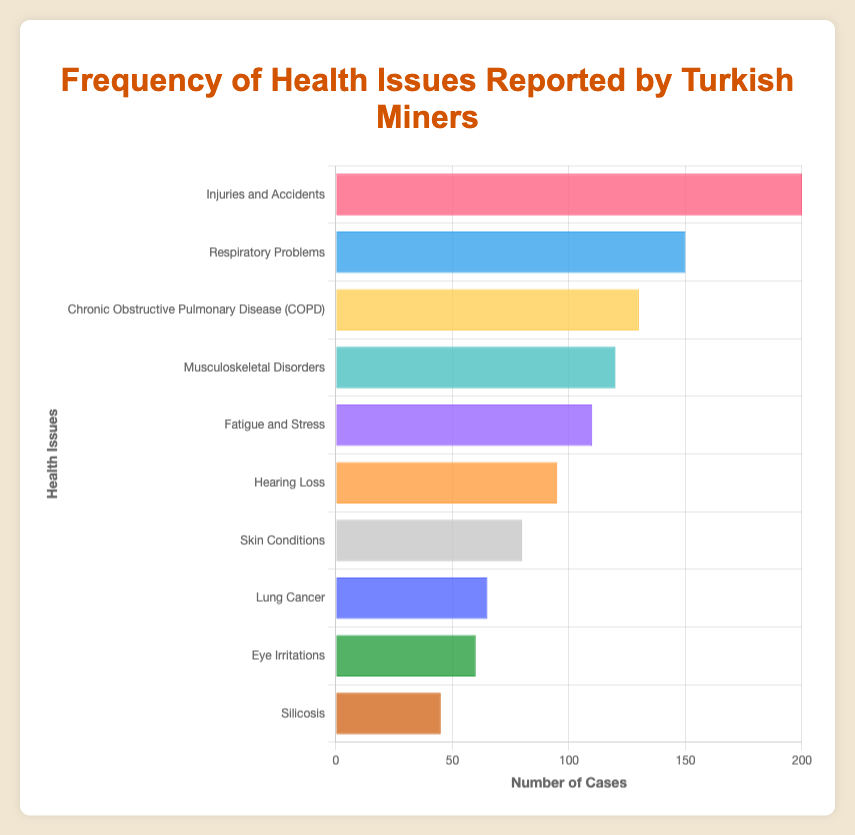What is the most frequently reported health issue among Turkish miners? By looking at the bar chart, the tallest bar represents the most frequently reported health issue. In this case, the bar for "Injuries and Accidents" is the tallest.
Answer: Injuries and Accidents How many more cases of "Respiratory Problems" are there compared to "Eye Irritations"? Referring to the figure, "Respiratory Problems" has a count of 150 cases and "Eye Irritations" has 60 cases. The difference is calculated as 150 - 60.
Answer: 90 Which health issue has fewer cases, "Silicosis" or "Skin Conditions"? By inspecting the length of the bars, "Silicosis" (45 cases) has fewer cases compared to "Skin Conditions" (80 cases).
Answer: Silicosis What is the total number of reported cases for "Lung Cancer" and "Hearing Loss"? Adding the number of cases for "Lung Cancer" (65) and "Hearing Loss" (95): 65 + 95.
Answer: 160 What is the average number of cases for "Fatigue and Stress", "Musculoskeletal Disorders", and "Chronic Obstructive Pulmonary Disease (COPD)"? Summing up the cases for "Fatigue and Stress" (110), "Musculoskeletal Disorders" (120), and "COPD" (130): 110 + 120 + 130 = 360. Then, divide by the number of health issues: 360/3.
Answer: 120 Are "Skin Conditions" reported more frequently than "Eye Irritations"? The figure shows that "Skin Conditions" has 80 cases, while "Eye Irritations" has 60 cases. Since 80 is greater than 60, "Skin Conditions" are more frequently reported.
Answer: Yes What is the second most reported health issue among Turkish miners after "Injuries and Accidents"? By comparing the lengths of the bars, the second tallest bar represents "Respiratory Problems" with 150 cases, just after "Injuries and Accidents" with 200 cases.
Answer: Respiratory Problems What is the combined total of the two least reported health issues? The figure shows that "Silicosis" has 45 cases and "Eye Irritations" has 60 cases. Adding these two values: 45 + 60.
Answer: 105 Which color represents the bar for "Silicosis"? The color of the bar representing "Silicosis", located at the bottom of the bar chart, is brown according to the provided color descriptions.
Answer: Brown 